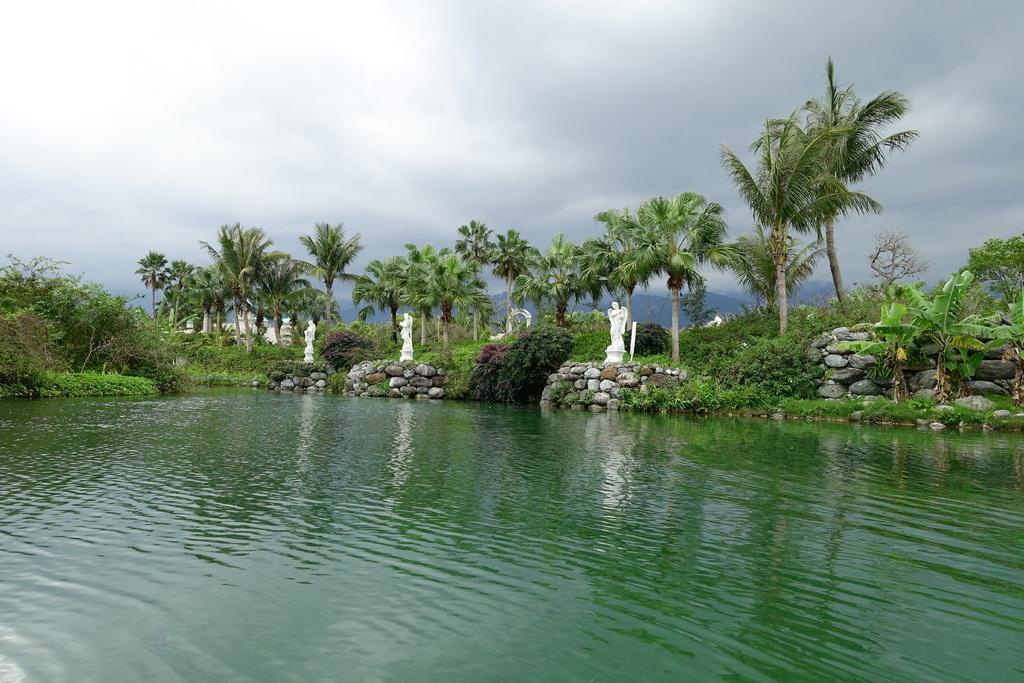In one or two sentences, can you explain what this image depicts? In this picture there are trees and there are statues and there is a building. At the top there is sky and there are clouds. At the bottom there is water. 